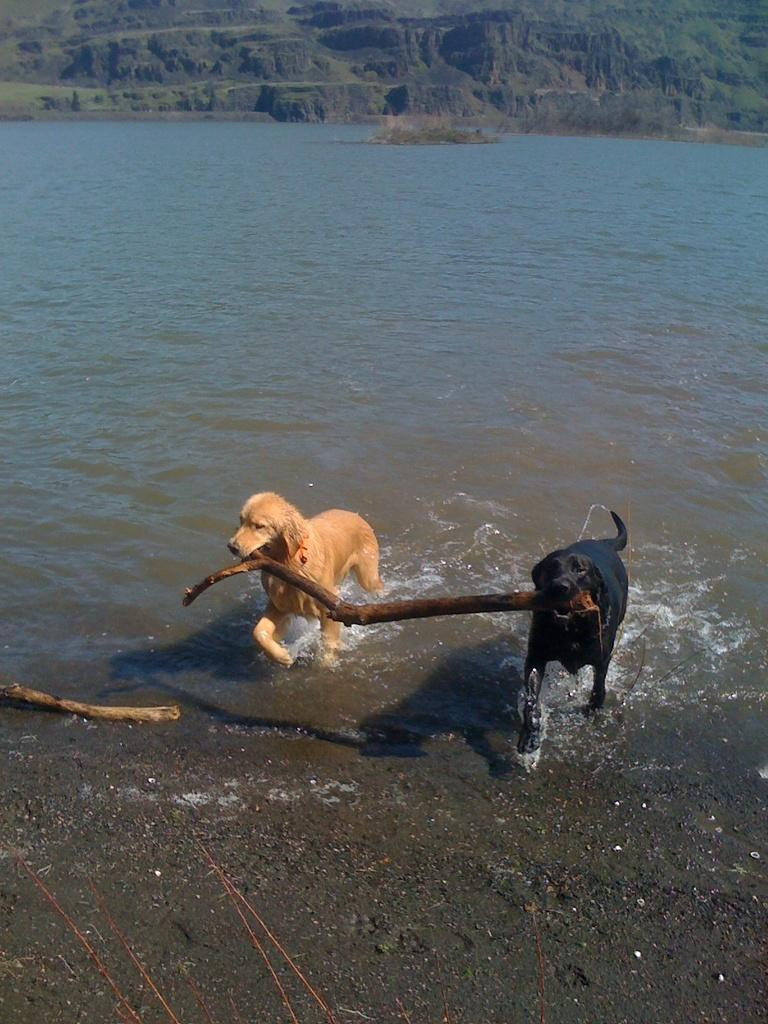How many dogs are in the image? There are two dogs in the image. What are the dogs doing in the image? The dogs are holding a stick with their mouths. Where are the dogs located in the image? The dogs are in water. What is visible at the bottom of the image? There is a stick on the land at the bottom of the image. What can be seen at the top of the image? There is a hill visible at the top of the image. What type of card is being played by the girl in the image? There is no girl or card present in the image; it features two dogs holding a stick in water. 